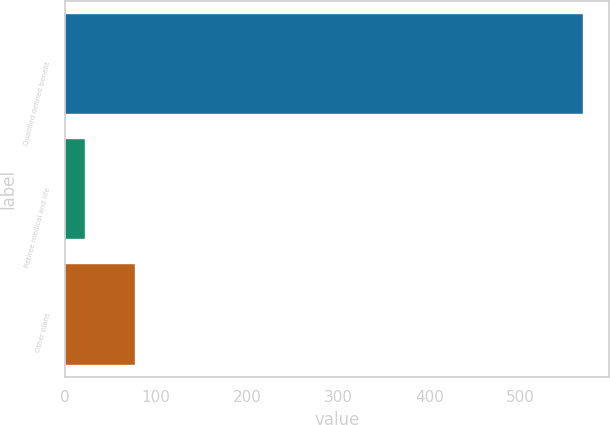<chart> <loc_0><loc_0><loc_500><loc_500><bar_chart><fcel>Qualified defined benefit<fcel>Retiree medical and life<fcel>Other plans<nl><fcel>568<fcel>22<fcel>76.6<nl></chart> 